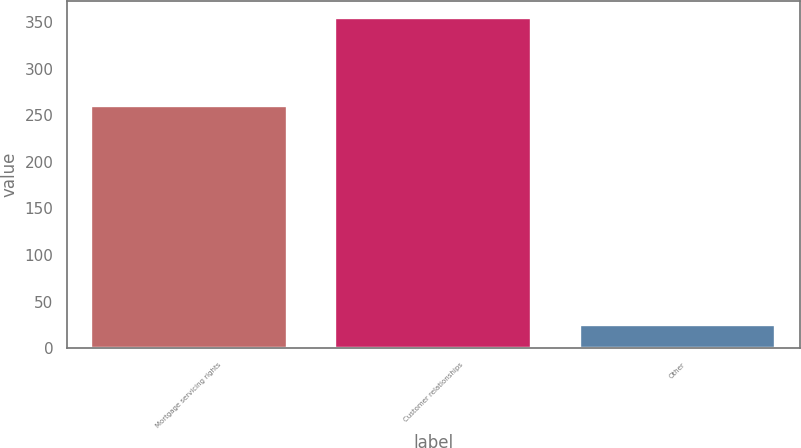Convert chart. <chart><loc_0><loc_0><loc_500><loc_500><bar_chart><fcel>Mortgage servicing rights<fcel>Customer relationships<fcel>Other<nl><fcel>260<fcel>355<fcel>25<nl></chart> 